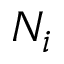<formula> <loc_0><loc_0><loc_500><loc_500>N _ { i }</formula> 